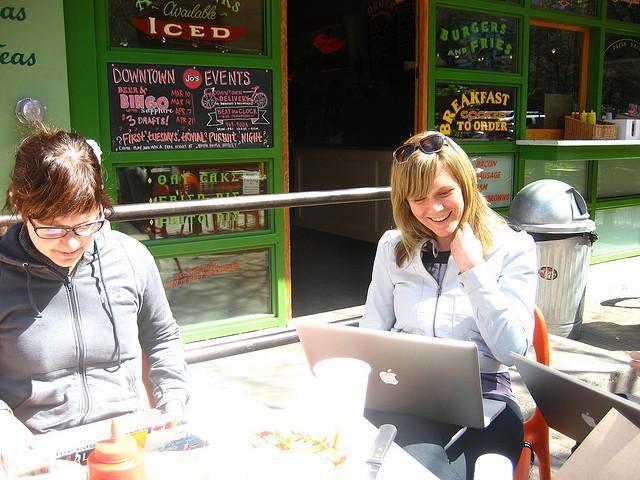How many people are in the picture?
Give a very brief answer. 2. How many laptops are there?
Give a very brief answer. 2. 